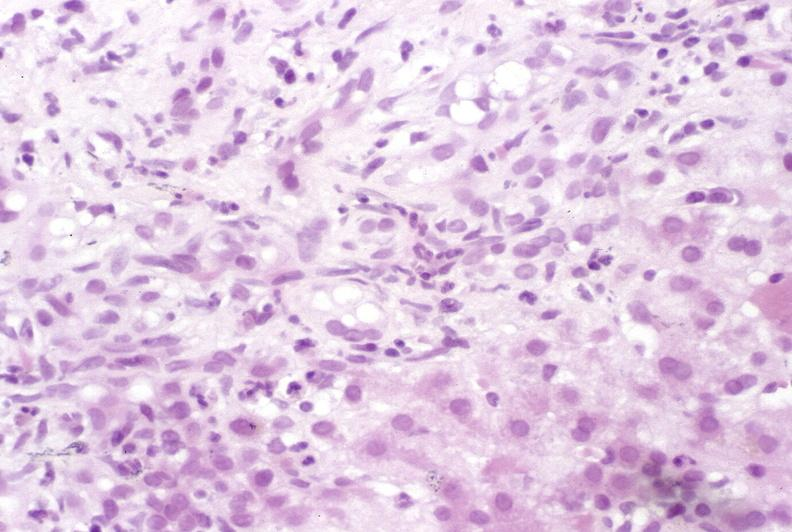s liver present?
Answer the question using a single word or phrase. Yes 